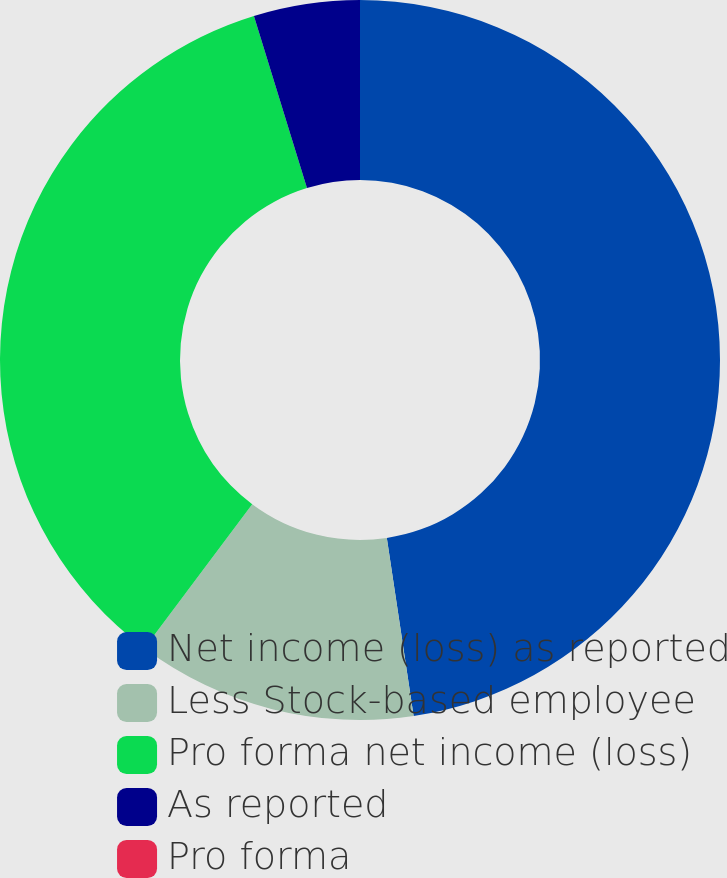Convert chart to OTSL. <chart><loc_0><loc_0><loc_500><loc_500><pie_chart><fcel>Net income (loss) as reported<fcel>Less Stock-based employee<fcel>Pro forma net income (loss)<fcel>As reported<fcel>Pro forma<nl><fcel>47.62%<fcel>12.6%<fcel>35.02%<fcel>4.76%<fcel>0.0%<nl></chart> 